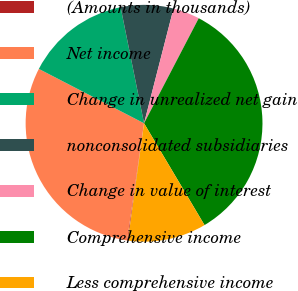Convert chart to OTSL. <chart><loc_0><loc_0><loc_500><loc_500><pie_chart><fcel>(Amounts in thousands)<fcel>Net income<fcel>Change in unrealized net gain<fcel>nonconsolidated subsidiaries<fcel>Change in value of interest<fcel>Comprehensive income<fcel>Less comprehensive income<nl><fcel>0.11%<fcel>30.3%<fcel>14.24%<fcel>7.17%<fcel>3.64%<fcel>33.83%<fcel>10.71%<nl></chart> 